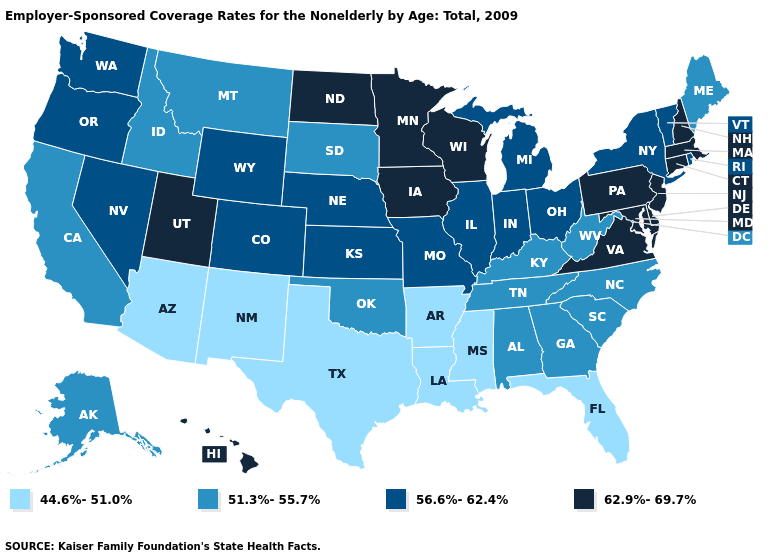What is the value of New York?
Quick response, please. 56.6%-62.4%. What is the value of Oregon?
Answer briefly. 56.6%-62.4%. Does Arizona have the lowest value in the West?
Quick response, please. Yes. Is the legend a continuous bar?
Be succinct. No. Name the states that have a value in the range 56.6%-62.4%?
Be succinct. Colorado, Illinois, Indiana, Kansas, Michigan, Missouri, Nebraska, Nevada, New York, Ohio, Oregon, Rhode Island, Vermont, Washington, Wyoming. Which states hav the highest value in the West?
Write a very short answer. Hawaii, Utah. Does Oklahoma have a higher value than Louisiana?
Answer briefly. Yes. Name the states that have a value in the range 44.6%-51.0%?
Quick response, please. Arizona, Arkansas, Florida, Louisiana, Mississippi, New Mexico, Texas. What is the value of Connecticut?
Answer briefly. 62.9%-69.7%. What is the highest value in the West ?
Answer briefly. 62.9%-69.7%. Does Nevada have the highest value in the USA?
Quick response, please. No. What is the value of Vermont?
Be succinct. 56.6%-62.4%. Which states have the lowest value in the West?
Be succinct. Arizona, New Mexico. Does the map have missing data?
Quick response, please. No. What is the highest value in the South ?
Quick response, please. 62.9%-69.7%. 